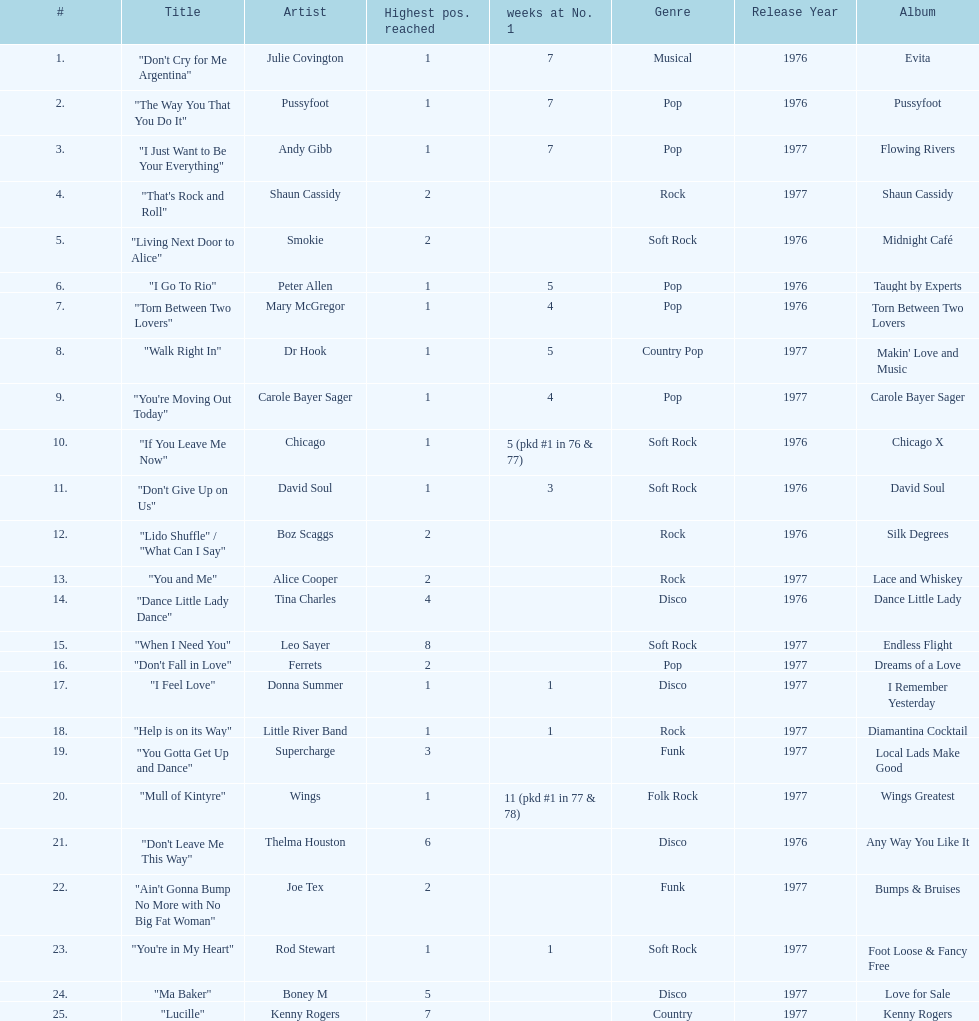How many weeks did julie covington's "don't cry for me argentina" spend at the top of australia's singles chart? 7. 